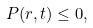<formula> <loc_0><loc_0><loc_500><loc_500>P ( r , t ) \leq 0 , \quad \</formula> 